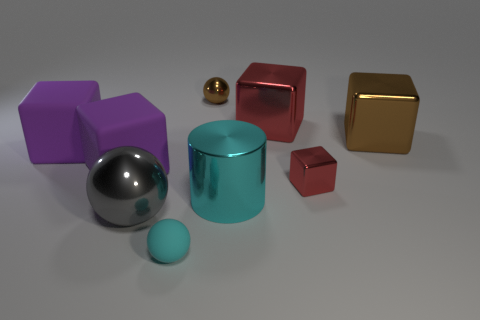There is a object that is the same color as the tiny metal block; what is its size?
Give a very brief answer. Large. Does the small matte ball have the same color as the metal cylinder?
Give a very brief answer. Yes. The brown ball is what size?
Make the answer very short. Small. How big is the metal object that is behind the large cyan shiny cylinder and left of the large cyan metallic object?
Your response must be concise. Small. There is a small thing in front of the large metallic cylinder; what shape is it?
Offer a terse response. Sphere. The tiny object that is in front of the brown ball and behind the gray metal object has what shape?
Your response must be concise. Cube. How many cyan objects are either small shiny balls or matte spheres?
Your response must be concise. 1. There is a tiny sphere in front of the small shiny sphere; is it the same color as the big shiny cylinder?
Offer a terse response. Yes. What size is the matte object on the right side of the gray object that is behind the small cyan rubber sphere?
Keep it short and to the point. Small. What material is the gray object that is the same size as the brown block?
Make the answer very short. Metal. 